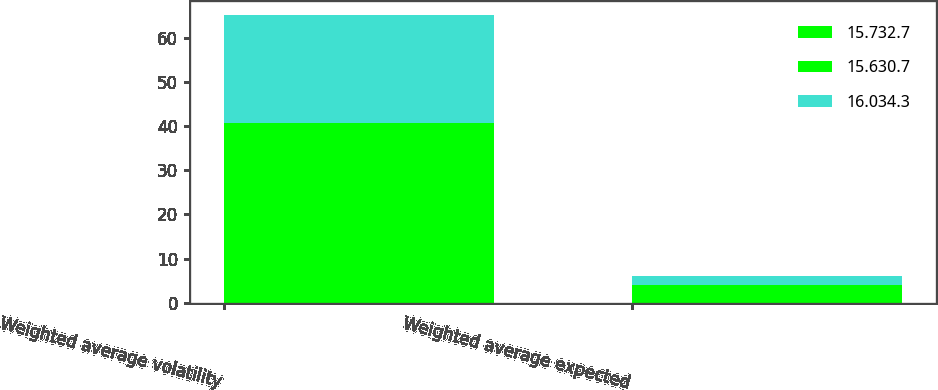<chart> <loc_0><loc_0><loc_500><loc_500><stacked_bar_chart><ecel><fcel>Weighted average volatility<fcel>Weighted average expected<nl><fcel>15.732.7<fcel>19.8<fcel>2<nl><fcel>15.630.7<fcel>21<fcel>1.9<nl><fcel>16.034.3<fcel>24.3<fcel>2.1<nl></chart> 